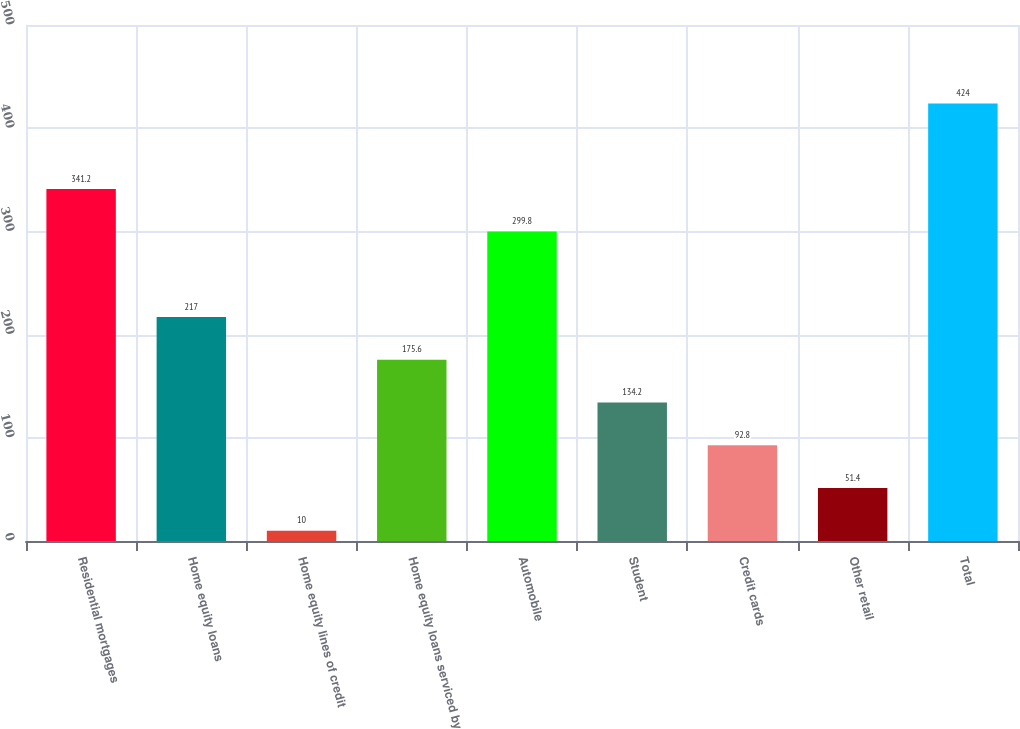Convert chart. <chart><loc_0><loc_0><loc_500><loc_500><bar_chart><fcel>Residential mortgages<fcel>Home equity loans<fcel>Home equity lines of credit<fcel>Home equity loans serviced by<fcel>Automobile<fcel>Student<fcel>Credit cards<fcel>Other retail<fcel>Total<nl><fcel>341.2<fcel>217<fcel>10<fcel>175.6<fcel>299.8<fcel>134.2<fcel>92.8<fcel>51.4<fcel>424<nl></chart> 